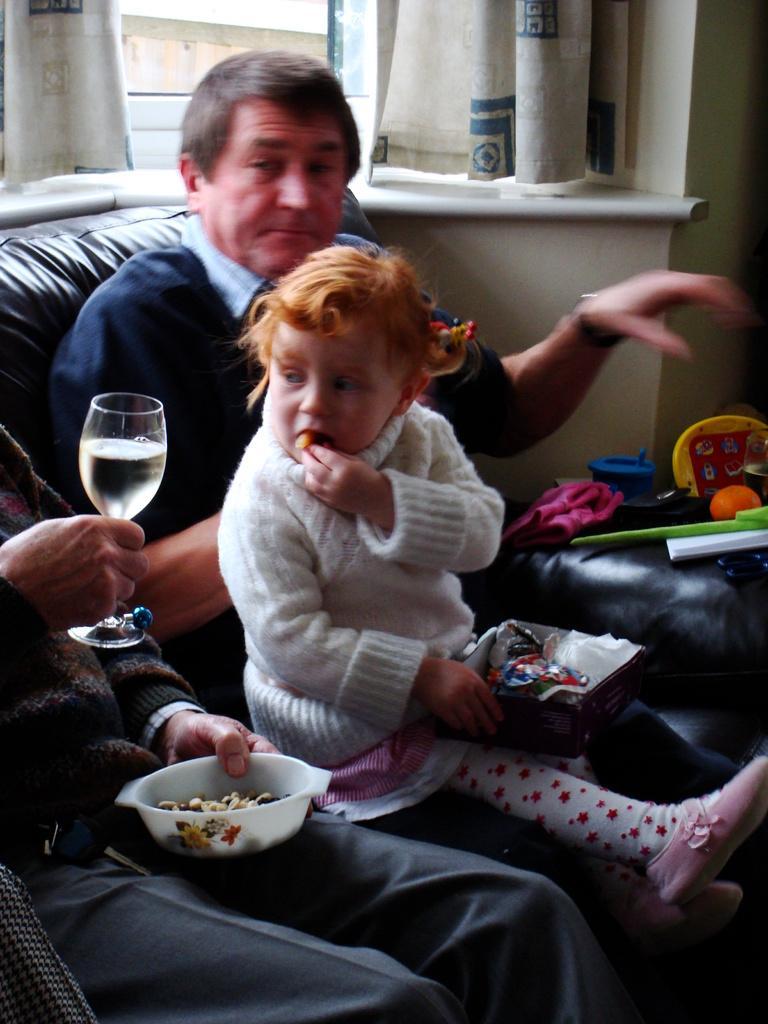Can you describe this image briefly? In the image we can see there are people sitting on the sofa and a man is holding wine glass and a bowl in his hand. 